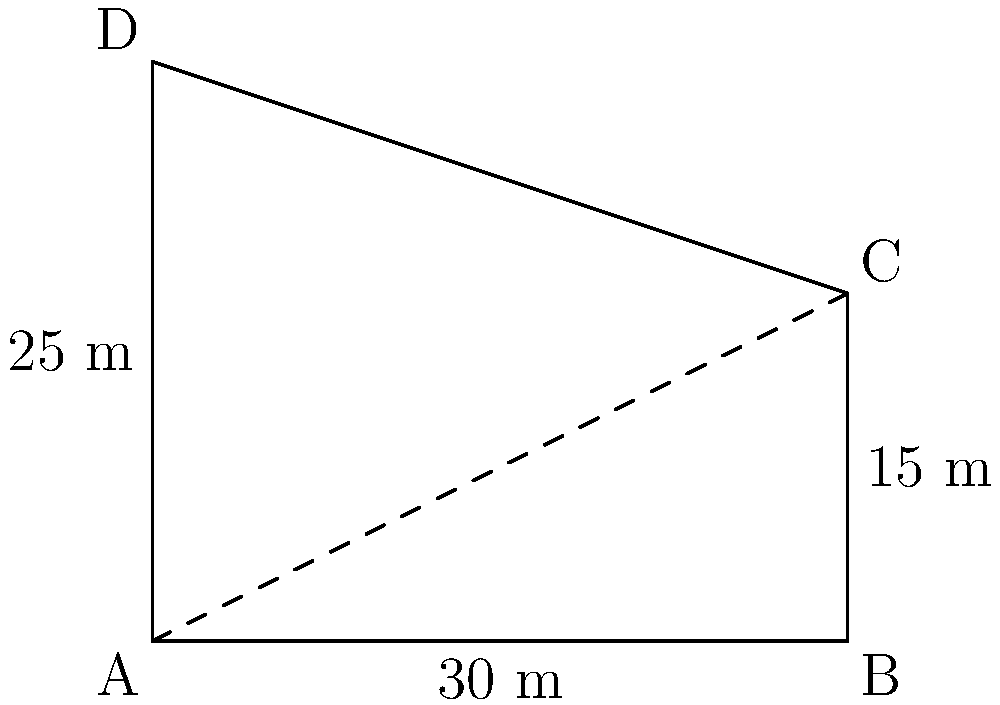During your visit to the historic Ulu Cami in Samsun, you decide to measure the height of its minaret using shadow measurements. At a specific time of day, you measure the shadow of the minaret to be 30 meters long. At the same time, you place a 3-meter stick vertically on the ground, which casts a shadow of 6 meters. What is the height of the minaret? Let's approach this step-by-step using the principle of similar triangles:

1) First, let's identify the triangles in our diagram:
   - Triangle ABC represents the stick and its shadow
   - Triangle ABD represents the minaret and its shadow

2) These triangles are similar because they share the same angle at A (created by the sun's rays) and both have a right angle (the stick and minaret are perpendicular to the ground).

3) In similar triangles, the ratios of corresponding sides are equal. Let's set up this proportion:

   $$\frac{\text{stick height}}{\text{stick shadow}} = \frac{\text{minaret height}}{\text{minaret shadow}}$$

4) We can fill in the known values:

   $$\frac{3}{6} = \frac{\text{minaret height}}{30}$$

5) Simplify the left side:

   $$\frac{1}{2} = \frac{\text{minaret height}}{30}$$

6) To solve for the minaret height, multiply both sides by 30:

   $$30 \cdot \frac{1}{2} = \text{minaret height}$$

7) Simplify:

   $$15 = \text{minaret height}$$

Therefore, the height of the minaret is 15 meters.
Answer: 15 meters 